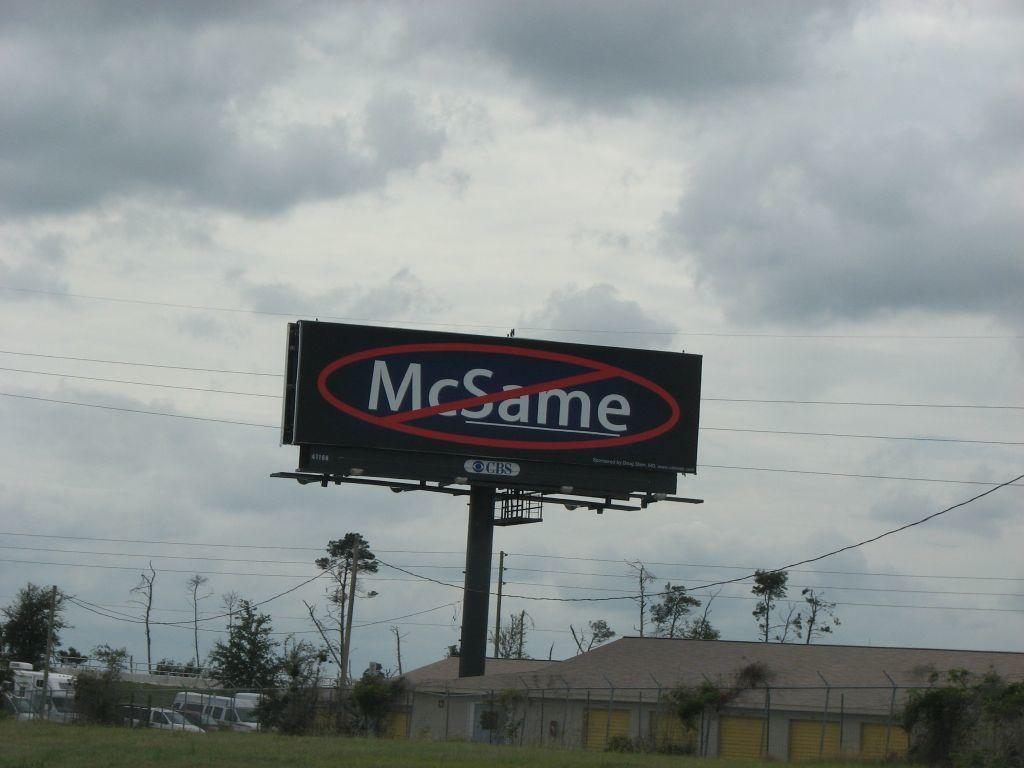<image>
Relay a brief, clear account of the picture shown. The huge billboard urged no more of the McSame! 